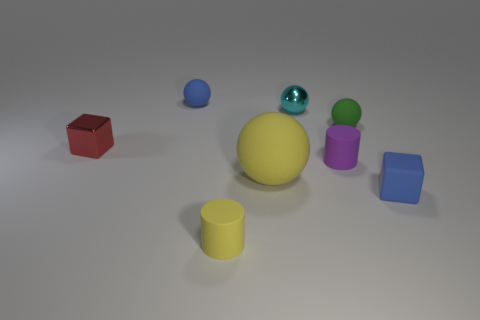Subtract 1 balls. How many balls are left? 3 Subtract all purple balls. Subtract all yellow cylinders. How many balls are left? 4 Add 1 small yellow metallic objects. How many objects exist? 9 Subtract all blocks. How many objects are left? 6 Subtract all shiny cubes. Subtract all large yellow rubber things. How many objects are left? 6 Add 1 cyan things. How many cyan things are left? 2 Add 4 cylinders. How many cylinders exist? 6 Subtract 1 yellow cylinders. How many objects are left? 7 